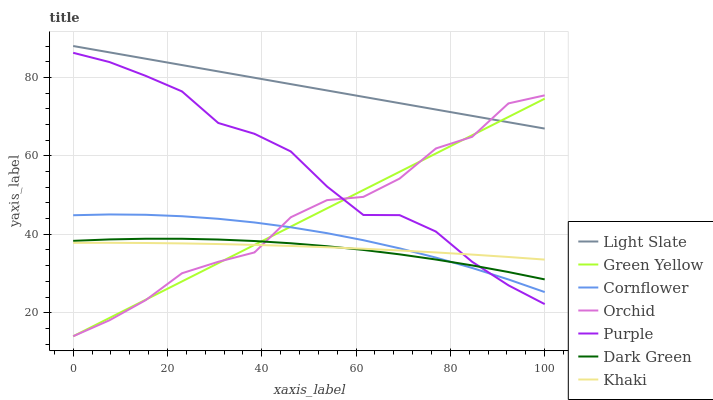Does Dark Green have the minimum area under the curve?
Answer yes or no. Yes. Does Light Slate have the maximum area under the curve?
Answer yes or no. Yes. Does Cornflower have the minimum area under the curve?
Answer yes or no. No. Does Cornflower have the maximum area under the curve?
Answer yes or no. No. Is Green Yellow the smoothest?
Answer yes or no. Yes. Is Orchid the roughest?
Answer yes or no. Yes. Is Cornflower the smoothest?
Answer yes or no. No. Is Cornflower the roughest?
Answer yes or no. No. Does Orchid have the lowest value?
Answer yes or no. Yes. Does Cornflower have the lowest value?
Answer yes or no. No. Does Light Slate have the highest value?
Answer yes or no. Yes. Does Cornflower have the highest value?
Answer yes or no. No. Is Dark Green less than Light Slate?
Answer yes or no. Yes. Is Light Slate greater than Cornflower?
Answer yes or no. Yes. Does Dark Green intersect Cornflower?
Answer yes or no. Yes. Is Dark Green less than Cornflower?
Answer yes or no. No. Is Dark Green greater than Cornflower?
Answer yes or no. No. Does Dark Green intersect Light Slate?
Answer yes or no. No. 